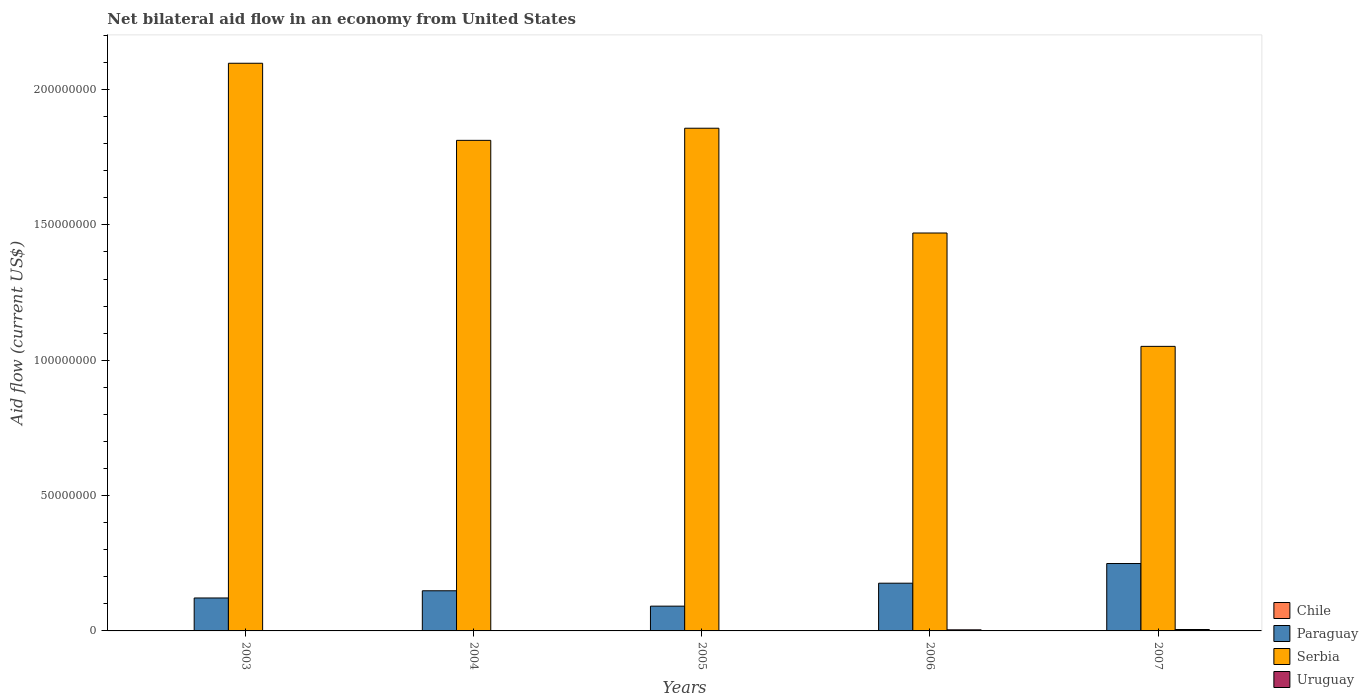Are the number of bars per tick equal to the number of legend labels?
Provide a succinct answer. No. How many bars are there on the 4th tick from the left?
Your answer should be compact. 3. In how many cases, is the number of bars for a given year not equal to the number of legend labels?
Offer a terse response. 5. What is the net bilateral aid flow in Chile in 2004?
Keep it short and to the point. 0. Across all years, what is the maximum net bilateral aid flow in Uruguay?
Provide a succinct answer. 5.20e+05. Across all years, what is the minimum net bilateral aid flow in Paraguay?
Provide a short and direct response. 9.15e+06. What is the total net bilateral aid flow in Uruguay in the graph?
Offer a terse response. 9.20e+05. What is the difference between the net bilateral aid flow in Serbia in 2003 and that in 2004?
Provide a succinct answer. 2.85e+07. What is the difference between the net bilateral aid flow in Serbia in 2003 and the net bilateral aid flow in Chile in 2005?
Your response must be concise. 2.10e+08. What is the average net bilateral aid flow in Serbia per year?
Give a very brief answer. 1.66e+08. In the year 2006, what is the difference between the net bilateral aid flow in Serbia and net bilateral aid flow in Uruguay?
Keep it short and to the point. 1.47e+08. In how many years, is the net bilateral aid flow in Paraguay greater than 130000000 US$?
Make the answer very short. 0. What is the ratio of the net bilateral aid flow in Paraguay in 2005 to that in 2006?
Offer a terse response. 0.52. Is the difference between the net bilateral aid flow in Serbia in 2006 and 2007 greater than the difference between the net bilateral aid flow in Uruguay in 2006 and 2007?
Your answer should be compact. Yes. What is the difference between the highest and the second highest net bilateral aid flow in Paraguay?
Keep it short and to the point. 7.27e+06. What is the difference between the highest and the lowest net bilateral aid flow in Serbia?
Keep it short and to the point. 1.05e+08. In how many years, is the net bilateral aid flow in Serbia greater than the average net bilateral aid flow in Serbia taken over all years?
Make the answer very short. 3. Is it the case that in every year, the sum of the net bilateral aid flow in Uruguay and net bilateral aid flow in Paraguay is greater than the sum of net bilateral aid flow in Serbia and net bilateral aid flow in Chile?
Offer a very short reply. Yes. How many years are there in the graph?
Give a very brief answer. 5. What is the difference between two consecutive major ticks on the Y-axis?
Ensure brevity in your answer.  5.00e+07. Are the values on the major ticks of Y-axis written in scientific E-notation?
Give a very brief answer. No. Does the graph contain any zero values?
Ensure brevity in your answer.  Yes. What is the title of the graph?
Give a very brief answer. Net bilateral aid flow in an economy from United States. Does "Bermuda" appear as one of the legend labels in the graph?
Make the answer very short. No. What is the label or title of the Y-axis?
Offer a very short reply. Aid flow (current US$). What is the Aid flow (current US$) of Paraguay in 2003?
Your response must be concise. 1.22e+07. What is the Aid flow (current US$) of Serbia in 2003?
Offer a terse response. 2.10e+08. What is the Aid flow (current US$) of Paraguay in 2004?
Give a very brief answer. 1.48e+07. What is the Aid flow (current US$) of Serbia in 2004?
Give a very brief answer. 1.81e+08. What is the Aid flow (current US$) of Paraguay in 2005?
Keep it short and to the point. 9.15e+06. What is the Aid flow (current US$) of Serbia in 2005?
Your answer should be very brief. 1.86e+08. What is the Aid flow (current US$) of Uruguay in 2005?
Provide a succinct answer. 0. What is the Aid flow (current US$) in Paraguay in 2006?
Keep it short and to the point. 1.76e+07. What is the Aid flow (current US$) of Serbia in 2006?
Provide a succinct answer. 1.47e+08. What is the Aid flow (current US$) of Uruguay in 2006?
Keep it short and to the point. 4.00e+05. What is the Aid flow (current US$) in Paraguay in 2007?
Offer a terse response. 2.49e+07. What is the Aid flow (current US$) in Serbia in 2007?
Your answer should be compact. 1.05e+08. What is the Aid flow (current US$) of Uruguay in 2007?
Provide a succinct answer. 5.20e+05. Across all years, what is the maximum Aid flow (current US$) in Paraguay?
Give a very brief answer. 2.49e+07. Across all years, what is the maximum Aid flow (current US$) in Serbia?
Ensure brevity in your answer.  2.10e+08. Across all years, what is the maximum Aid flow (current US$) in Uruguay?
Keep it short and to the point. 5.20e+05. Across all years, what is the minimum Aid flow (current US$) in Paraguay?
Offer a very short reply. 9.15e+06. Across all years, what is the minimum Aid flow (current US$) of Serbia?
Give a very brief answer. 1.05e+08. Across all years, what is the minimum Aid flow (current US$) in Uruguay?
Your answer should be compact. 0. What is the total Aid flow (current US$) in Paraguay in the graph?
Give a very brief answer. 7.87e+07. What is the total Aid flow (current US$) of Serbia in the graph?
Give a very brief answer. 8.29e+08. What is the total Aid flow (current US$) of Uruguay in the graph?
Provide a short and direct response. 9.20e+05. What is the difference between the Aid flow (current US$) of Paraguay in 2003 and that in 2004?
Provide a succinct answer. -2.66e+06. What is the difference between the Aid flow (current US$) of Serbia in 2003 and that in 2004?
Ensure brevity in your answer.  2.85e+07. What is the difference between the Aid flow (current US$) in Paraguay in 2003 and that in 2005?
Your response must be concise. 3.02e+06. What is the difference between the Aid flow (current US$) of Serbia in 2003 and that in 2005?
Your answer should be compact. 2.40e+07. What is the difference between the Aid flow (current US$) in Paraguay in 2003 and that in 2006?
Provide a short and direct response. -5.46e+06. What is the difference between the Aid flow (current US$) in Serbia in 2003 and that in 2006?
Provide a succinct answer. 6.27e+07. What is the difference between the Aid flow (current US$) in Paraguay in 2003 and that in 2007?
Your answer should be compact. -1.27e+07. What is the difference between the Aid flow (current US$) in Serbia in 2003 and that in 2007?
Your answer should be compact. 1.05e+08. What is the difference between the Aid flow (current US$) of Paraguay in 2004 and that in 2005?
Offer a terse response. 5.68e+06. What is the difference between the Aid flow (current US$) in Serbia in 2004 and that in 2005?
Your response must be concise. -4.48e+06. What is the difference between the Aid flow (current US$) of Paraguay in 2004 and that in 2006?
Give a very brief answer. -2.80e+06. What is the difference between the Aid flow (current US$) of Serbia in 2004 and that in 2006?
Ensure brevity in your answer.  3.42e+07. What is the difference between the Aid flow (current US$) in Paraguay in 2004 and that in 2007?
Your answer should be very brief. -1.01e+07. What is the difference between the Aid flow (current US$) of Serbia in 2004 and that in 2007?
Make the answer very short. 7.61e+07. What is the difference between the Aid flow (current US$) of Paraguay in 2005 and that in 2006?
Your answer should be very brief. -8.48e+06. What is the difference between the Aid flow (current US$) of Serbia in 2005 and that in 2006?
Your answer should be compact. 3.87e+07. What is the difference between the Aid flow (current US$) in Paraguay in 2005 and that in 2007?
Your answer should be compact. -1.58e+07. What is the difference between the Aid flow (current US$) of Serbia in 2005 and that in 2007?
Provide a succinct answer. 8.06e+07. What is the difference between the Aid flow (current US$) of Paraguay in 2006 and that in 2007?
Keep it short and to the point. -7.27e+06. What is the difference between the Aid flow (current US$) in Serbia in 2006 and that in 2007?
Provide a short and direct response. 4.19e+07. What is the difference between the Aid flow (current US$) in Paraguay in 2003 and the Aid flow (current US$) in Serbia in 2004?
Give a very brief answer. -1.69e+08. What is the difference between the Aid flow (current US$) of Paraguay in 2003 and the Aid flow (current US$) of Serbia in 2005?
Offer a terse response. -1.74e+08. What is the difference between the Aid flow (current US$) in Paraguay in 2003 and the Aid flow (current US$) in Serbia in 2006?
Your response must be concise. -1.35e+08. What is the difference between the Aid flow (current US$) in Paraguay in 2003 and the Aid flow (current US$) in Uruguay in 2006?
Make the answer very short. 1.18e+07. What is the difference between the Aid flow (current US$) in Serbia in 2003 and the Aid flow (current US$) in Uruguay in 2006?
Provide a succinct answer. 2.09e+08. What is the difference between the Aid flow (current US$) of Paraguay in 2003 and the Aid flow (current US$) of Serbia in 2007?
Offer a very short reply. -9.30e+07. What is the difference between the Aid flow (current US$) in Paraguay in 2003 and the Aid flow (current US$) in Uruguay in 2007?
Give a very brief answer. 1.16e+07. What is the difference between the Aid flow (current US$) in Serbia in 2003 and the Aid flow (current US$) in Uruguay in 2007?
Your answer should be compact. 2.09e+08. What is the difference between the Aid flow (current US$) in Paraguay in 2004 and the Aid flow (current US$) in Serbia in 2005?
Ensure brevity in your answer.  -1.71e+08. What is the difference between the Aid flow (current US$) in Paraguay in 2004 and the Aid flow (current US$) in Serbia in 2006?
Provide a short and direct response. -1.32e+08. What is the difference between the Aid flow (current US$) of Paraguay in 2004 and the Aid flow (current US$) of Uruguay in 2006?
Your response must be concise. 1.44e+07. What is the difference between the Aid flow (current US$) in Serbia in 2004 and the Aid flow (current US$) in Uruguay in 2006?
Your response must be concise. 1.81e+08. What is the difference between the Aid flow (current US$) of Paraguay in 2004 and the Aid flow (current US$) of Serbia in 2007?
Provide a short and direct response. -9.03e+07. What is the difference between the Aid flow (current US$) of Paraguay in 2004 and the Aid flow (current US$) of Uruguay in 2007?
Make the answer very short. 1.43e+07. What is the difference between the Aid flow (current US$) of Serbia in 2004 and the Aid flow (current US$) of Uruguay in 2007?
Provide a succinct answer. 1.81e+08. What is the difference between the Aid flow (current US$) of Paraguay in 2005 and the Aid flow (current US$) of Serbia in 2006?
Your answer should be very brief. -1.38e+08. What is the difference between the Aid flow (current US$) in Paraguay in 2005 and the Aid flow (current US$) in Uruguay in 2006?
Make the answer very short. 8.75e+06. What is the difference between the Aid flow (current US$) of Serbia in 2005 and the Aid flow (current US$) of Uruguay in 2006?
Your response must be concise. 1.85e+08. What is the difference between the Aid flow (current US$) in Paraguay in 2005 and the Aid flow (current US$) in Serbia in 2007?
Give a very brief answer. -9.60e+07. What is the difference between the Aid flow (current US$) of Paraguay in 2005 and the Aid flow (current US$) of Uruguay in 2007?
Provide a short and direct response. 8.63e+06. What is the difference between the Aid flow (current US$) in Serbia in 2005 and the Aid flow (current US$) in Uruguay in 2007?
Keep it short and to the point. 1.85e+08. What is the difference between the Aid flow (current US$) in Paraguay in 2006 and the Aid flow (current US$) in Serbia in 2007?
Your answer should be very brief. -8.75e+07. What is the difference between the Aid flow (current US$) of Paraguay in 2006 and the Aid flow (current US$) of Uruguay in 2007?
Offer a terse response. 1.71e+07. What is the difference between the Aid flow (current US$) in Serbia in 2006 and the Aid flow (current US$) in Uruguay in 2007?
Make the answer very short. 1.46e+08. What is the average Aid flow (current US$) of Paraguay per year?
Give a very brief answer. 1.57e+07. What is the average Aid flow (current US$) in Serbia per year?
Offer a very short reply. 1.66e+08. What is the average Aid flow (current US$) of Uruguay per year?
Keep it short and to the point. 1.84e+05. In the year 2003, what is the difference between the Aid flow (current US$) of Paraguay and Aid flow (current US$) of Serbia?
Your response must be concise. -1.98e+08. In the year 2004, what is the difference between the Aid flow (current US$) of Paraguay and Aid flow (current US$) of Serbia?
Give a very brief answer. -1.66e+08. In the year 2005, what is the difference between the Aid flow (current US$) of Paraguay and Aid flow (current US$) of Serbia?
Ensure brevity in your answer.  -1.77e+08. In the year 2006, what is the difference between the Aid flow (current US$) in Paraguay and Aid flow (current US$) in Serbia?
Offer a terse response. -1.29e+08. In the year 2006, what is the difference between the Aid flow (current US$) in Paraguay and Aid flow (current US$) in Uruguay?
Your answer should be compact. 1.72e+07. In the year 2006, what is the difference between the Aid flow (current US$) in Serbia and Aid flow (current US$) in Uruguay?
Your response must be concise. 1.47e+08. In the year 2007, what is the difference between the Aid flow (current US$) of Paraguay and Aid flow (current US$) of Serbia?
Your response must be concise. -8.02e+07. In the year 2007, what is the difference between the Aid flow (current US$) of Paraguay and Aid flow (current US$) of Uruguay?
Give a very brief answer. 2.44e+07. In the year 2007, what is the difference between the Aid flow (current US$) in Serbia and Aid flow (current US$) in Uruguay?
Your response must be concise. 1.05e+08. What is the ratio of the Aid flow (current US$) of Paraguay in 2003 to that in 2004?
Make the answer very short. 0.82. What is the ratio of the Aid flow (current US$) of Serbia in 2003 to that in 2004?
Keep it short and to the point. 1.16. What is the ratio of the Aid flow (current US$) of Paraguay in 2003 to that in 2005?
Your answer should be compact. 1.33. What is the ratio of the Aid flow (current US$) in Serbia in 2003 to that in 2005?
Your answer should be very brief. 1.13. What is the ratio of the Aid flow (current US$) of Paraguay in 2003 to that in 2006?
Your response must be concise. 0.69. What is the ratio of the Aid flow (current US$) in Serbia in 2003 to that in 2006?
Provide a short and direct response. 1.43. What is the ratio of the Aid flow (current US$) in Paraguay in 2003 to that in 2007?
Give a very brief answer. 0.49. What is the ratio of the Aid flow (current US$) of Serbia in 2003 to that in 2007?
Provide a short and direct response. 2. What is the ratio of the Aid flow (current US$) of Paraguay in 2004 to that in 2005?
Provide a short and direct response. 1.62. What is the ratio of the Aid flow (current US$) in Serbia in 2004 to that in 2005?
Your answer should be very brief. 0.98. What is the ratio of the Aid flow (current US$) of Paraguay in 2004 to that in 2006?
Ensure brevity in your answer.  0.84. What is the ratio of the Aid flow (current US$) in Serbia in 2004 to that in 2006?
Give a very brief answer. 1.23. What is the ratio of the Aid flow (current US$) in Paraguay in 2004 to that in 2007?
Offer a terse response. 0.6. What is the ratio of the Aid flow (current US$) in Serbia in 2004 to that in 2007?
Provide a succinct answer. 1.72. What is the ratio of the Aid flow (current US$) in Paraguay in 2005 to that in 2006?
Offer a very short reply. 0.52. What is the ratio of the Aid flow (current US$) in Serbia in 2005 to that in 2006?
Your answer should be very brief. 1.26. What is the ratio of the Aid flow (current US$) in Paraguay in 2005 to that in 2007?
Your answer should be very brief. 0.37. What is the ratio of the Aid flow (current US$) of Serbia in 2005 to that in 2007?
Your answer should be compact. 1.77. What is the ratio of the Aid flow (current US$) in Paraguay in 2006 to that in 2007?
Give a very brief answer. 0.71. What is the ratio of the Aid flow (current US$) in Serbia in 2006 to that in 2007?
Give a very brief answer. 1.4. What is the ratio of the Aid flow (current US$) in Uruguay in 2006 to that in 2007?
Your answer should be compact. 0.77. What is the difference between the highest and the second highest Aid flow (current US$) of Paraguay?
Offer a terse response. 7.27e+06. What is the difference between the highest and the second highest Aid flow (current US$) in Serbia?
Ensure brevity in your answer.  2.40e+07. What is the difference between the highest and the lowest Aid flow (current US$) of Paraguay?
Ensure brevity in your answer.  1.58e+07. What is the difference between the highest and the lowest Aid flow (current US$) of Serbia?
Keep it short and to the point. 1.05e+08. What is the difference between the highest and the lowest Aid flow (current US$) of Uruguay?
Your response must be concise. 5.20e+05. 